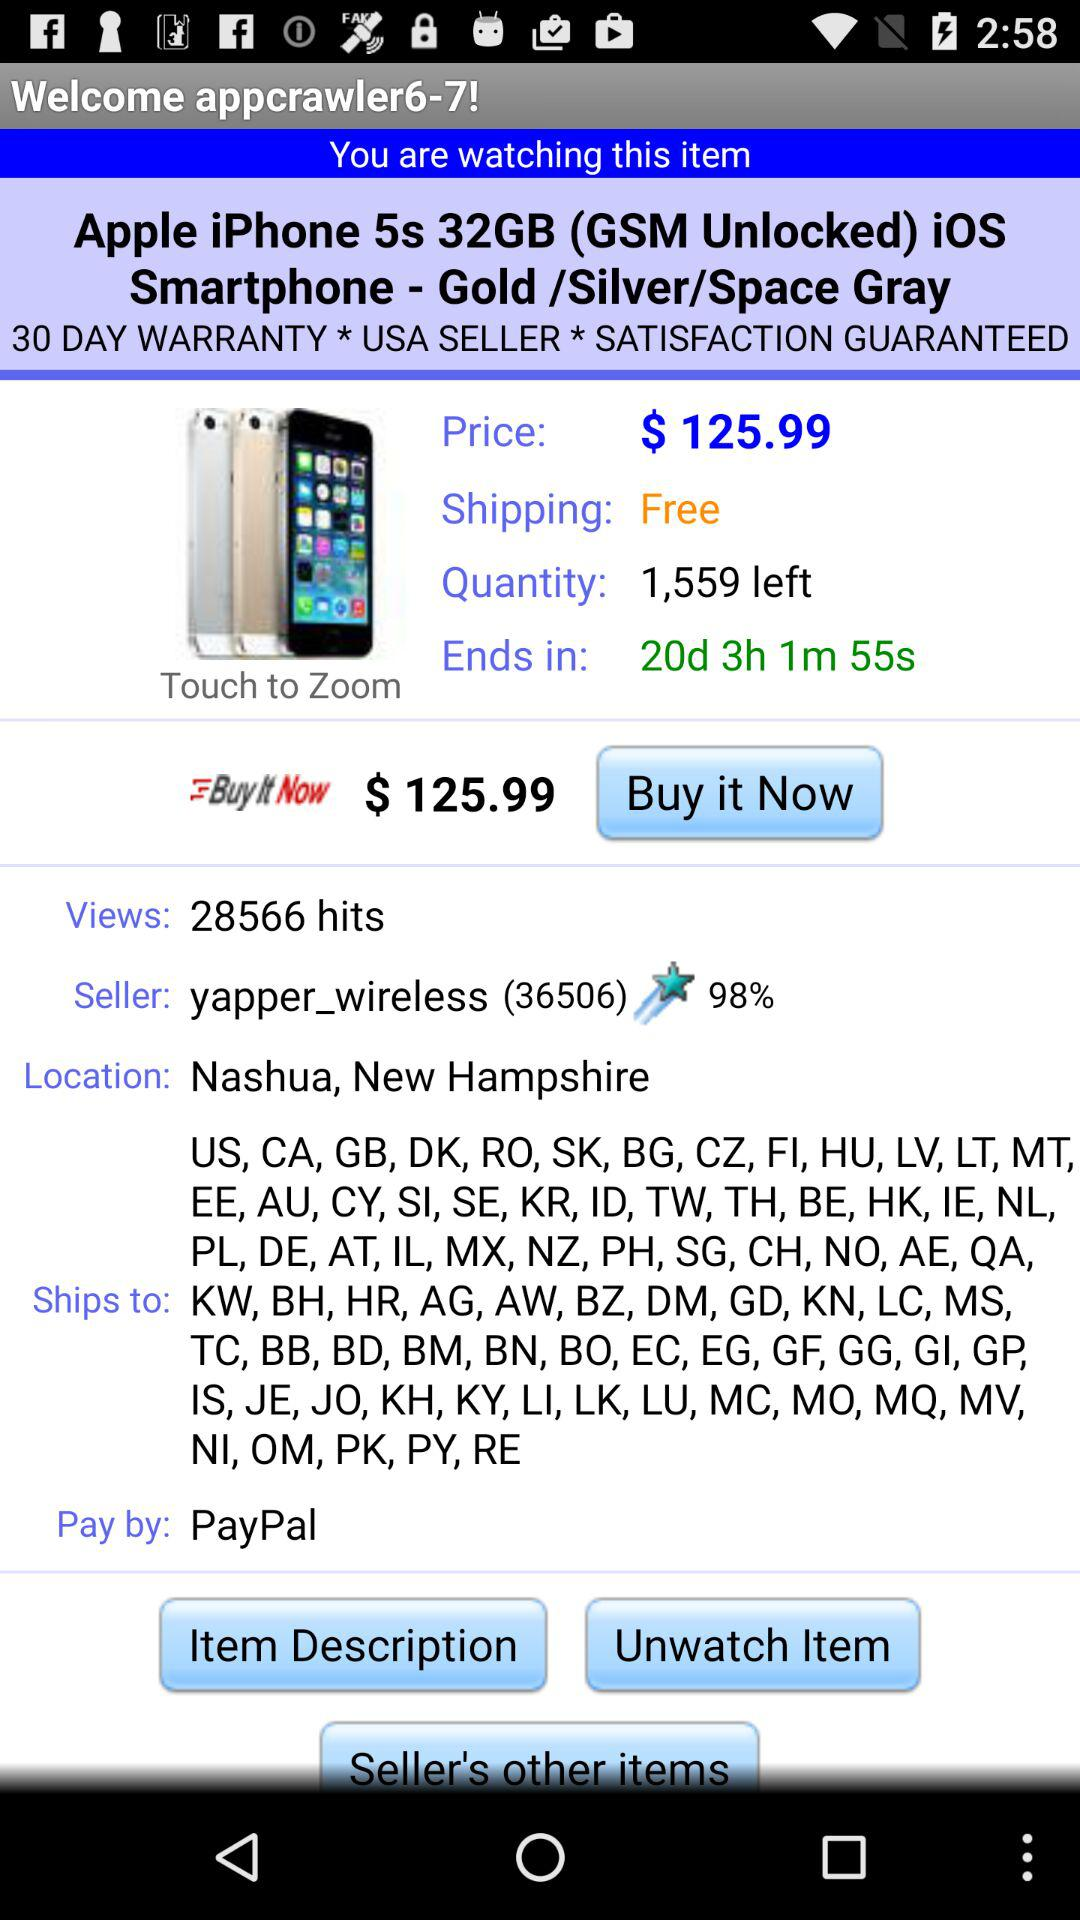How many views are there? There are 28566 views. 